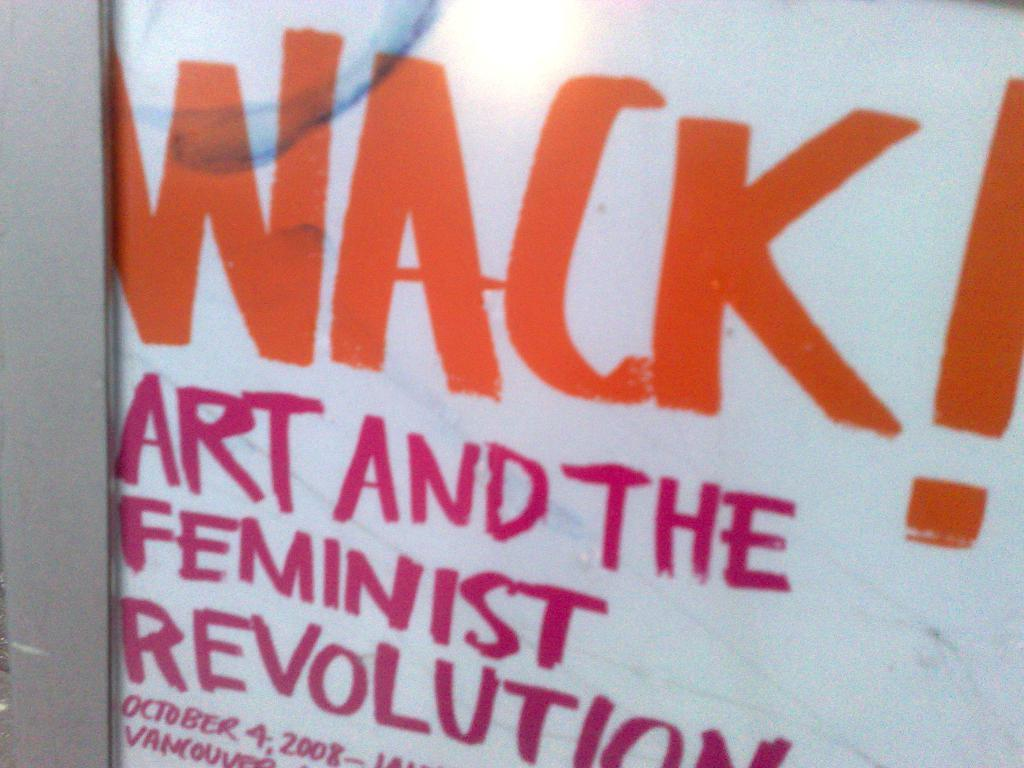Provide a one-sentence caption for the provided image. A poster about Art and the Feminist Revolution. 